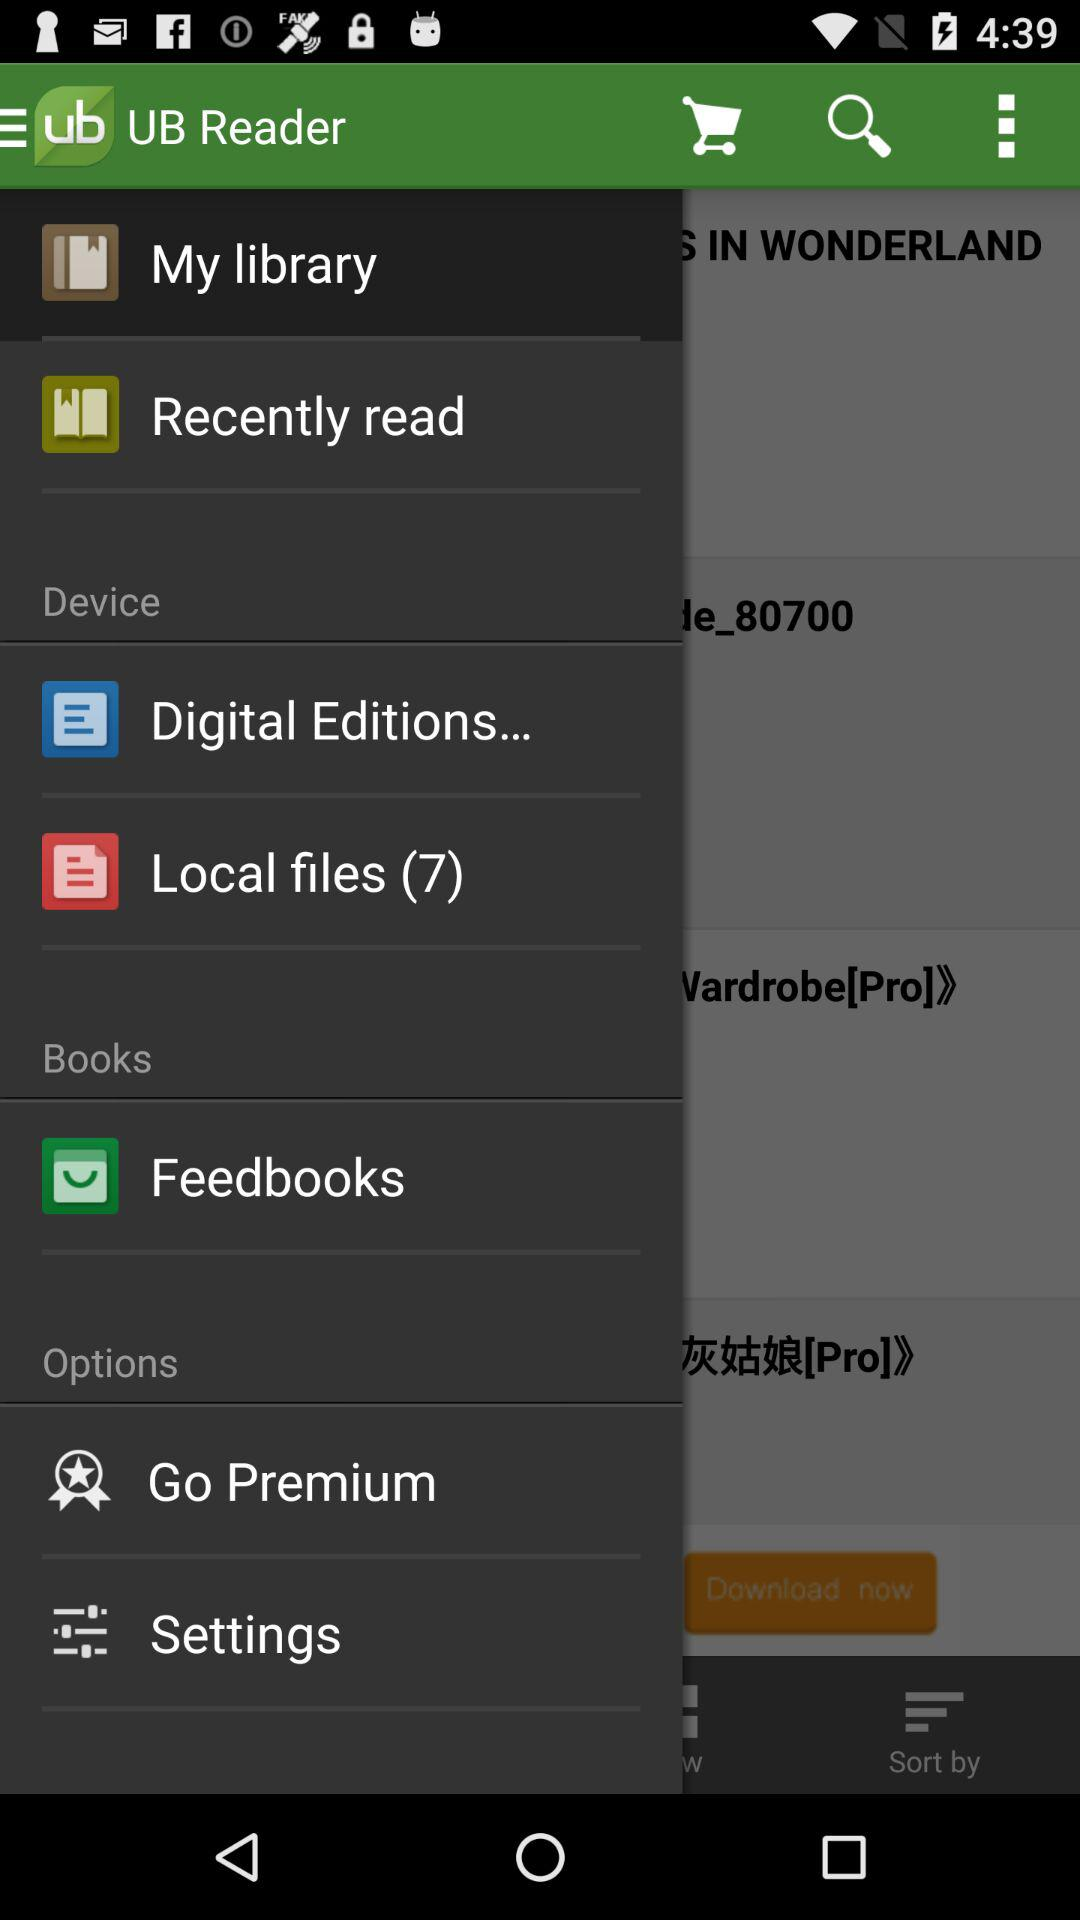Which is the selected item in the menu? The selected item is "My library". 